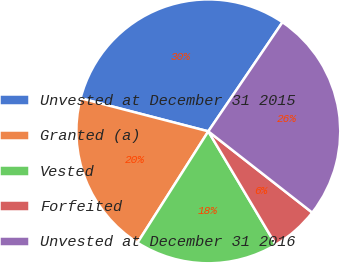<chart> <loc_0><loc_0><loc_500><loc_500><pie_chart><fcel>Unvested at December 31 2015<fcel>Granted (a)<fcel>Vested<fcel>Forfeited<fcel>Unvested at December 31 2016<nl><fcel>30.47%<fcel>20.02%<fcel>17.56%<fcel>5.89%<fcel>26.06%<nl></chart> 